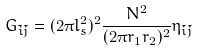<formula> <loc_0><loc_0><loc_500><loc_500>G _ { \tilde { i } \tilde { j } } = ( 2 \pi l _ { s } ^ { 2 } ) ^ { 2 } \frac { N ^ { 2 } } { ( 2 \pi r _ { 1 } r _ { 2 } ) ^ { 2 } } \eta _ { \tilde { i } \tilde { j } }</formula> 